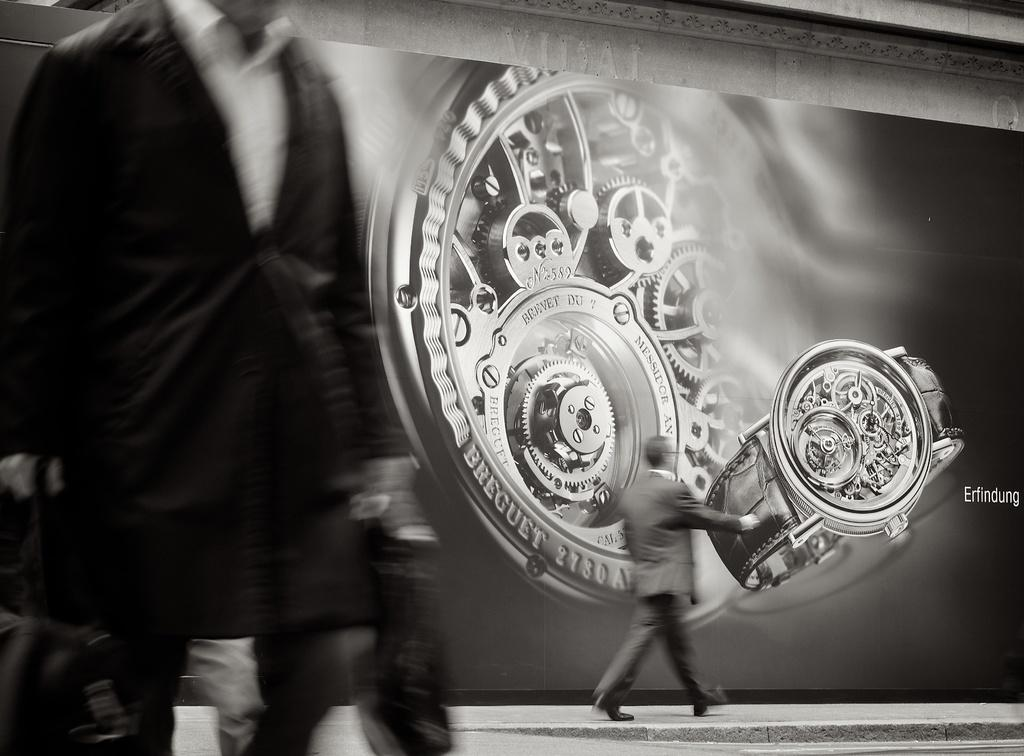Provide a one-sentence caption for the provided image. A watch advertisement in black and white from the company Breguet. 